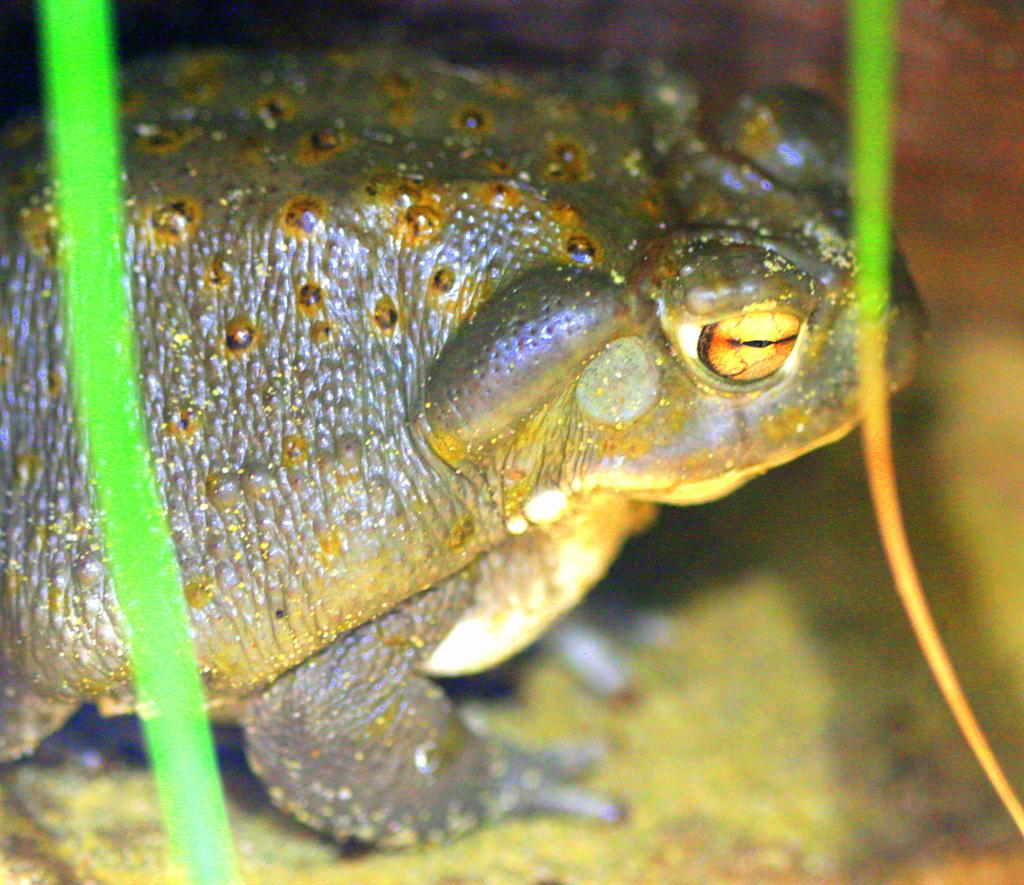What type of animal is present in the image? There is a frog in the image. What news channel is the frog watching in the image? There is no television or news channel present in the image; it only features a frog. 